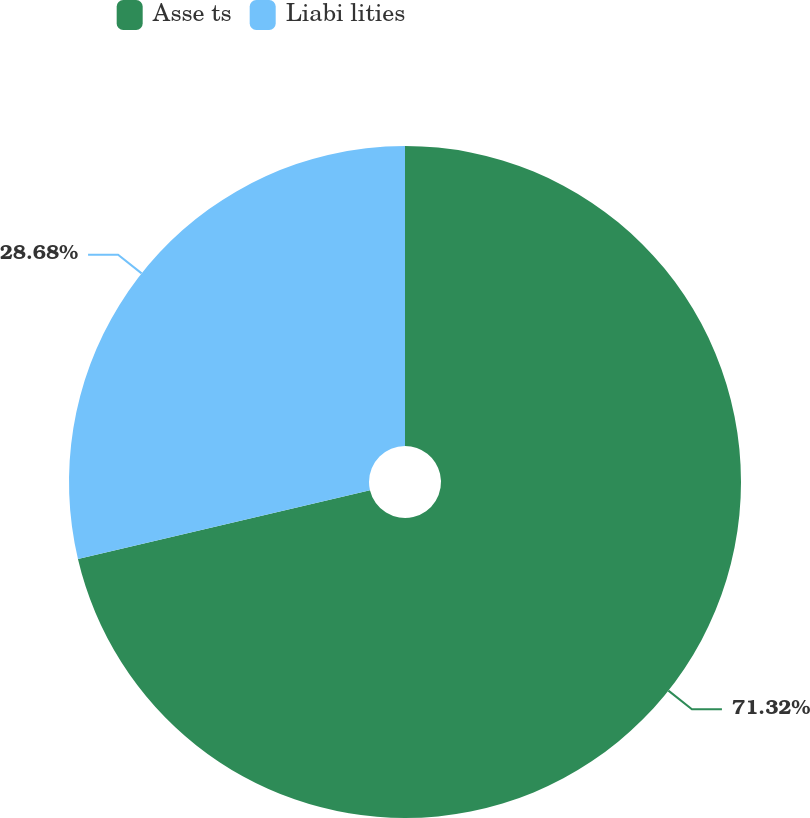<chart> <loc_0><loc_0><loc_500><loc_500><pie_chart><fcel>Asse ts<fcel>Liabi lities<nl><fcel>71.32%<fcel>28.68%<nl></chart> 